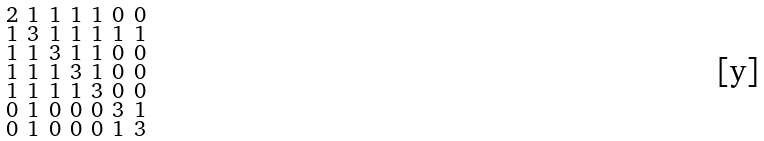<formula> <loc_0><loc_0><loc_500><loc_500>\begin{smallmatrix} 2 & 1 & 1 & 1 & 1 & 0 & 0 \\ 1 & 3 & 1 & 1 & 1 & 1 & 1 \\ 1 & 1 & 3 & 1 & 1 & 0 & 0 \\ 1 & 1 & 1 & 3 & 1 & 0 & 0 \\ 1 & 1 & 1 & 1 & 3 & 0 & 0 \\ 0 & 1 & 0 & 0 & 0 & 3 & 1 \\ 0 & 1 & 0 & 0 & 0 & 1 & 3 \end{smallmatrix}</formula> 